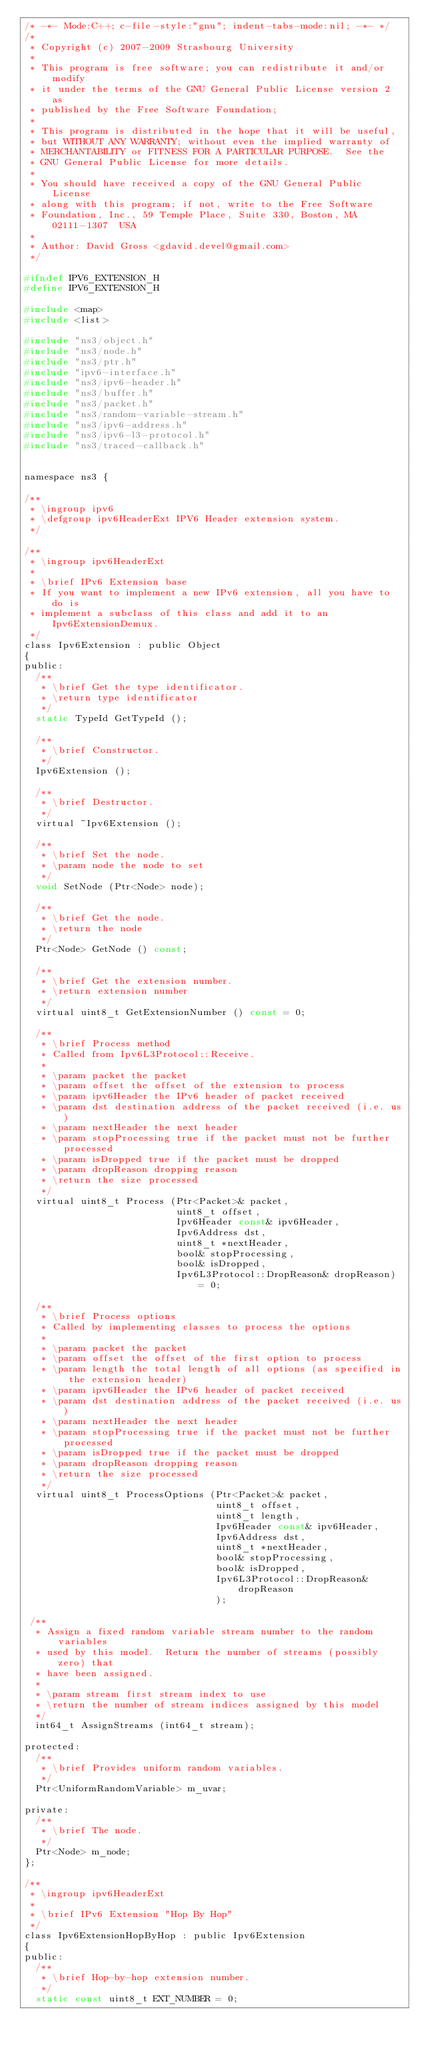<code> <loc_0><loc_0><loc_500><loc_500><_C_>/* -*- Mode:C++; c-file-style:"gnu"; indent-tabs-mode:nil; -*- */
/*
 * Copyright (c) 2007-2009 Strasbourg University
 *
 * This program is free software; you can redistribute it and/or modify
 * it under the terms of the GNU General Public License version 2 as
 * published by the Free Software Foundation;
 *
 * This program is distributed in the hope that it will be useful,
 * but WITHOUT ANY WARRANTY; without even the implied warranty of
 * MERCHANTABILITY or FITNESS FOR A PARTICULAR PURPOSE.  See the
 * GNU General Public License for more details.
 *
 * You should have received a copy of the GNU General Public License
 * along with this program; if not, write to the Free Software
 * Foundation, Inc., 59 Temple Place, Suite 330, Boston, MA  02111-1307  USA
 *
 * Author: David Gross <gdavid.devel@gmail.com>
 */

#ifndef IPV6_EXTENSION_H
#define IPV6_EXTENSION_H

#include <map>
#include <list>

#include "ns3/object.h"
#include "ns3/node.h"
#include "ns3/ptr.h"
#include "ipv6-interface.h"
#include "ns3/ipv6-header.h"
#include "ns3/buffer.h"
#include "ns3/packet.h"
#include "ns3/random-variable-stream.h"
#include "ns3/ipv6-address.h"
#include "ns3/ipv6-l3-protocol.h"
#include "ns3/traced-callback.h"


namespace ns3 {

/**
 * \ingroup ipv6
 * \defgroup ipv6HeaderExt IPV6 Header extension system.
 */

/**
 * \ingroup ipv6HeaderExt
 *
 * \brief IPv6 Extension base
 * If you want to implement a new IPv6 extension, all you have to do is
 * implement a subclass of this class and add it to an Ipv6ExtensionDemux.
 */
class Ipv6Extension : public Object
{
public:
  /**
   * \brief Get the type identificator.
   * \return type identificator
   */
  static TypeId GetTypeId ();

  /**
   * \brief Constructor.
   */
  Ipv6Extension ();

  /**
   * \brief Destructor.
   */
  virtual ~Ipv6Extension ();

  /**
   * \brief Set the node.
   * \param node the node to set
   */
  void SetNode (Ptr<Node> node);

  /**
   * \brief Get the node.
   * \return the node
   */
  Ptr<Node> GetNode () const;

  /**
   * \brief Get the extension number.
   * \return extension number
   */
  virtual uint8_t GetExtensionNumber () const = 0;

  /**
   * \brief Process method
   * Called from Ipv6L3Protocol::Receive.
   *
   * \param packet the packet
   * \param offset the offset of the extension to process
   * \param ipv6Header the IPv6 header of packet received
   * \param dst destination address of the packet received (i.e. us)
   * \param nextHeader the next header
   * \param stopProcessing true if the packet must not be further processed
   * \param isDropped true if the packet must be dropped
   * \param dropReason dropping reason
   * \return the size processed
   */
  virtual uint8_t Process (Ptr<Packet>& packet,
                           uint8_t offset,
                           Ipv6Header const& ipv6Header,
                           Ipv6Address dst,
                           uint8_t *nextHeader,
                           bool& stopProcessing,
                           bool& isDropped,
                           Ipv6L3Protocol::DropReason& dropReason) = 0;

  /**
   * \brief Process options
   * Called by implementing classes to process the options
   *
   * \param packet the packet
   * \param offset the offset of the first option to process
   * \param length the total length of all options (as specified in the extension header)
   * \param ipv6Header the IPv6 header of packet received
   * \param dst destination address of the packet received (i.e. us)
   * \param nextHeader the next header
   * \param stopProcessing true if the packet must not be further processed
   * \param isDropped true if the packet must be dropped
   * \param dropReason dropping reason
   * \return the size processed
   */
  virtual uint8_t ProcessOptions (Ptr<Packet>& packet,
                                  uint8_t offset,
                                  uint8_t length,
                                  Ipv6Header const& ipv6Header,
                                  Ipv6Address dst,
                                  uint8_t *nextHeader,
                                  bool& stopProcessing,
                                  bool& isDropped,
                                  Ipv6L3Protocol::DropReason& dropReason
                                  );

 /**
  * Assign a fixed random variable stream number to the random variables
  * used by this model.  Return the number of streams (possibly zero) that
  * have been assigned.
  *
  * \param stream first stream index to use
  * \return the number of stream indices assigned by this model
  */
  int64_t AssignStreams (int64_t stream);

protected:
  /**
   * \brief Provides uniform random variables.
   */
  Ptr<UniformRandomVariable> m_uvar;

private:
  /**
   * \brief The node.
   */
  Ptr<Node> m_node;
};

/**
 * \ingroup ipv6HeaderExt
 *
 * \brief IPv6 Extension "Hop By Hop"
 */
class Ipv6ExtensionHopByHop : public Ipv6Extension
{
public:
  /**
   * \brief Hop-by-hop extension number.
   */
  static const uint8_t EXT_NUMBER = 0;
</code> 